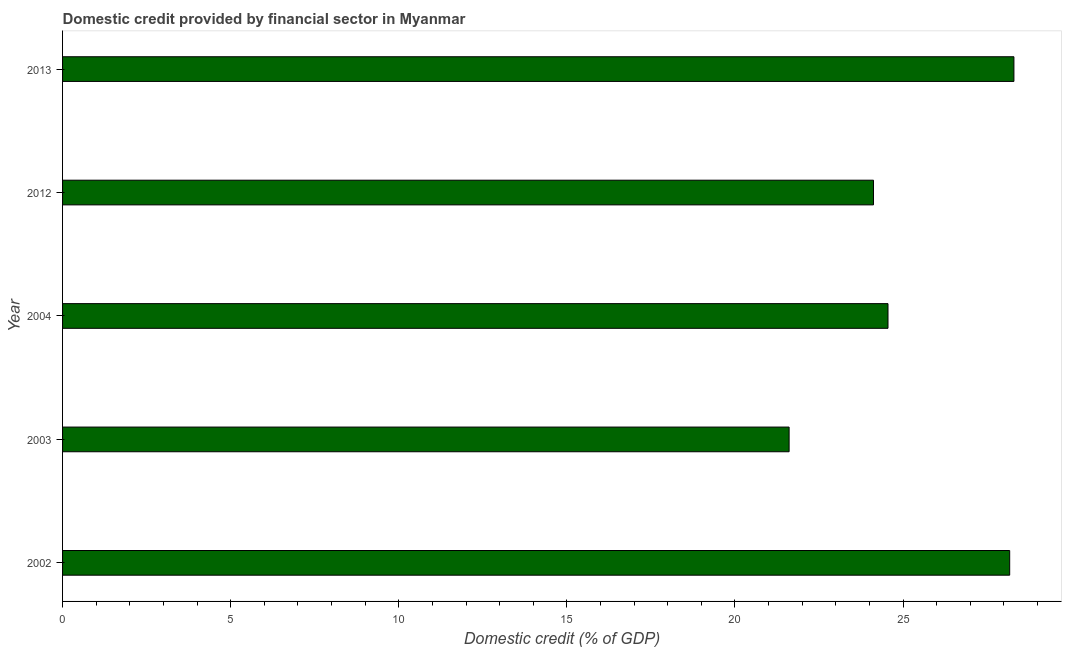What is the title of the graph?
Give a very brief answer. Domestic credit provided by financial sector in Myanmar. What is the label or title of the X-axis?
Provide a succinct answer. Domestic credit (% of GDP). What is the label or title of the Y-axis?
Ensure brevity in your answer.  Year. What is the domestic credit provided by financial sector in 2003?
Your answer should be very brief. 21.61. Across all years, what is the maximum domestic credit provided by financial sector?
Keep it short and to the point. 28.3. Across all years, what is the minimum domestic credit provided by financial sector?
Offer a very short reply. 21.61. In which year was the domestic credit provided by financial sector minimum?
Offer a very short reply. 2003. What is the sum of the domestic credit provided by financial sector?
Offer a very short reply. 126.75. What is the difference between the domestic credit provided by financial sector in 2003 and 2012?
Provide a succinct answer. -2.51. What is the average domestic credit provided by financial sector per year?
Your response must be concise. 25.35. What is the median domestic credit provided by financial sector?
Provide a short and direct response. 24.55. What is the difference between the highest and the second highest domestic credit provided by financial sector?
Offer a terse response. 0.13. Is the sum of the domestic credit provided by financial sector in 2003 and 2013 greater than the maximum domestic credit provided by financial sector across all years?
Provide a short and direct response. Yes. What is the difference between the highest and the lowest domestic credit provided by financial sector?
Keep it short and to the point. 6.69. In how many years, is the domestic credit provided by financial sector greater than the average domestic credit provided by financial sector taken over all years?
Keep it short and to the point. 2. What is the difference between two consecutive major ticks on the X-axis?
Provide a succinct answer. 5. What is the Domestic credit (% of GDP) of 2002?
Make the answer very short. 28.17. What is the Domestic credit (% of GDP) in 2003?
Your response must be concise. 21.61. What is the Domestic credit (% of GDP) of 2004?
Ensure brevity in your answer.  24.55. What is the Domestic credit (% of GDP) of 2012?
Ensure brevity in your answer.  24.12. What is the Domestic credit (% of GDP) in 2013?
Your response must be concise. 28.3. What is the difference between the Domestic credit (% of GDP) in 2002 and 2003?
Provide a short and direct response. 6.56. What is the difference between the Domestic credit (% of GDP) in 2002 and 2004?
Offer a terse response. 3.62. What is the difference between the Domestic credit (% of GDP) in 2002 and 2012?
Make the answer very short. 4.05. What is the difference between the Domestic credit (% of GDP) in 2002 and 2013?
Make the answer very short. -0.13. What is the difference between the Domestic credit (% of GDP) in 2003 and 2004?
Offer a very short reply. -2.94. What is the difference between the Domestic credit (% of GDP) in 2003 and 2012?
Give a very brief answer. -2.51. What is the difference between the Domestic credit (% of GDP) in 2003 and 2013?
Provide a short and direct response. -6.69. What is the difference between the Domestic credit (% of GDP) in 2004 and 2012?
Make the answer very short. 0.43. What is the difference between the Domestic credit (% of GDP) in 2004 and 2013?
Your answer should be very brief. -3.75. What is the difference between the Domestic credit (% of GDP) in 2012 and 2013?
Offer a very short reply. -4.18. What is the ratio of the Domestic credit (% of GDP) in 2002 to that in 2003?
Your answer should be very brief. 1.3. What is the ratio of the Domestic credit (% of GDP) in 2002 to that in 2004?
Offer a very short reply. 1.15. What is the ratio of the Domestic credit (% of GDP) in 2002 to that in 2012?
Offer a terse response. 1.17. What is the ratio of the Domestic credit (% of GDP) in 2003 to that in 2004?
Keep it short and to the point. 0.88. What is the ratio of the Domestic credit (% of GDP) in 2003 to that in 2012?
Your response must be concise. 0.9. What is the ratio of the Domestic credit (% of GDP) in 2003 to that in 2013?
Give a very brief answer. 0.76. What is the ratio of the Domestic credit (% of GDP) in 2004 to that in 2013?
Provide a succinct answer. 0.87. What is the ratio of the Domestic credit (% of GDP) in 2012 to that in 2013?
Give a very brief answer. 0.85. 